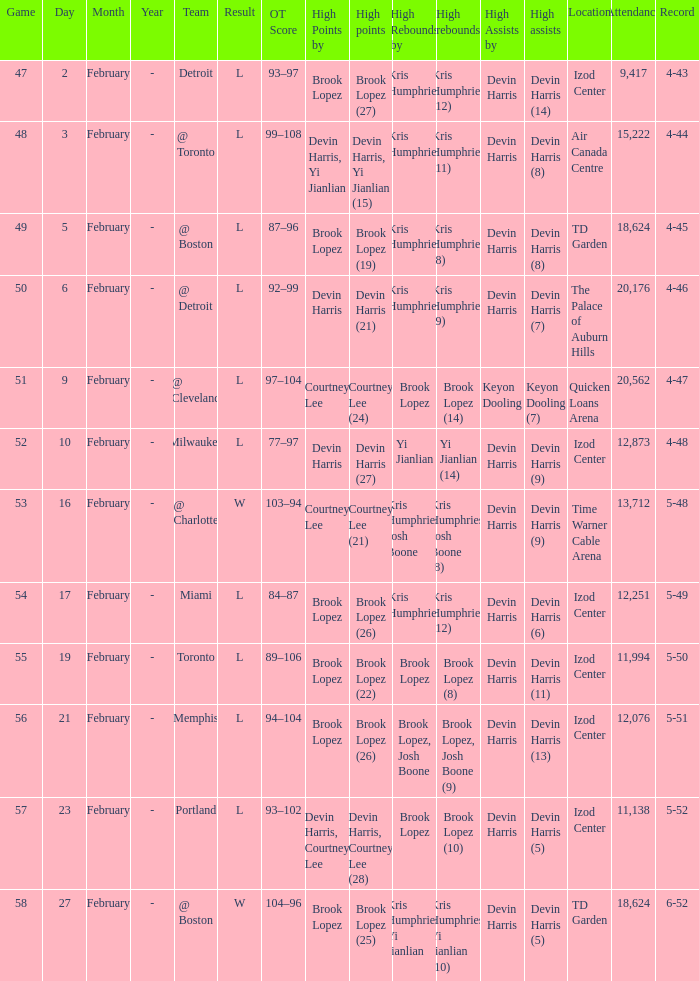What team was the game on February 27 played against? @ Boston. Give me the full table as a dictionary. {'header': ['Game', 'Day', 'Month', 'Year', 'Team', 'Result', 'OT Score', 'High Points by', 'High points', 'High Rebounds by', 'High rebounds', 'High Assists by', 'High assists', 'Location', 'Attendance', 'Record'], 'rows': [['47', '2', 'February', '-', 'Detroit', 'L', '93–97', 'Brook Lopez', 'Brook Lopez (27)', 'Kris Humphries', 'Kris Humphries (12)', 'Devin Harris', 'Devin Harris (14)', 'Izod Center', '9,417', '4-43'], ['48', '3', 'February', '-', '@ Toronto', 'L', '99–108', 'Devin Harris, Yi Jianlian', 'Devin Harris, Yi Jianlian (15)', 'Kris Humphries', 'Kris Humphries (11)', 'Devin Harris', 'Devin Harris (8)', 'Air Canada Centre', '15,222', '4-44'], ['49', '5', 'February', '-', '@ Boston', 'L', '87–96', 'Brook Lopez', 'Brook Lopez (19)', 'Kris Humphries', 'Kris Humphries (8)', 'Devin Harris', 'Devin Harris (8)', 'TD Garden', '18,624', '4-45'], ['50', '6', 'February', '-', '@ Detroit', 'L', '92–99', 'Devin Harris', 'Devin Harris (21)', 'Kris Humphries', 'Kris Humphries (9)', 'Devin Harris', 'Devin Harris (7)', 'The Palace of Auburn Hills', '20,176', '4-46'], ['51', '9', 'February', '-', '@ Cleveland', 'L', '97–104', 'Courtney Lee', 'Courtney Lee (24)', 'Brook Lopez', 'Brook Lopez (14)', 'Keyon Dooling', 'Keyon Dooling (7)', 'Quicken Loans Arena', '20,562', '4-47'], ['52', '10', 'February', '-', 'Milwaukee', 'L', '77–97', 'Devin Harris', 'Devin Harris (27)', 'Yi Jianlian', 'Yi Jianlian (14)', 'Devin Harris', 'Devin Harris (9)', 'Izod Center', '12,873', '4-48'], ['53', '16', 'February', '-', '@ Charlotte', 'W', '103–94', 'Courtney Lee', 'Courtney Lee (21)', 'Kris Humphries, Josh Boone', 'Kris Humphries, Josh Boone (8)', 'Devin Harris', 'Devin Harris (9)', 'Time Warner Cable Arena', '13,712', '5-48'], ['54', '17', 'February', '-', 'Miami', 'L', '84–87', 'Brook Lopez', 'Brook Lopez (26)', 'Kris Humphries', 'Kris Humphries (12)', 'Devin Harris', 'Devin Harris (6)', 'Izod Center', '12,251', '5-49'], ['55', '19', 'February', '-', 'Toronto', 'L', '89–106', 'Brook Lopez', 'Brook Lopez (22)', 'Brook Lopez', 'Brook Lopez (8)', 'Devin Harris', 'Devin Harris (11)', 'Izod Center', '11,994', '5-50'], ['56', '21', 'February', '-', 'Memphis', 'L', '94–104', 'Brook Lopez', 'Brook Lopez (26)', 'Brook Lopez, Josh Boone', 'Brook Lopez, Josh Boone (9)', 'Devin Harris', 'Devin Harris (13)', 'Izod Center', '12,076', '5-51'], ['57', '23', 'February', '-', 'Portland', 'L', '93–102', 'Devin Harris, Courtney Lee', 'Devin Harris, Courtney Lee (28)', 'Brook Lopez', 'Brook Lopez (10)', 'Devin Harris', 'Devin Harris (5)', 'Izod Center', '11,138', '5-52'], ['58', '27', 'February', '-', '@ Boston', 'W', '104–96', 'Brook Lopez', 'Brook Lopez (25)', 'Kris Humphries, Yi Jianlian', 'Kris Humphries, Yi Jianlian (10)', 'Devin Harris', 'Devin Harris (5)', 'TD Garden', '18,624', '6-52']]} 